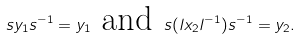Convert formula to latex. <formula><loc_0><loc_0><loc_500><loc_500>s y _ { 1 } s ^ { - 1 } = y _ { 1 } \text { and } s ( l x _ { 2 } l ^ { - 1 } ) s ^ { - 1 } = y _ { 2 } .</formula> 